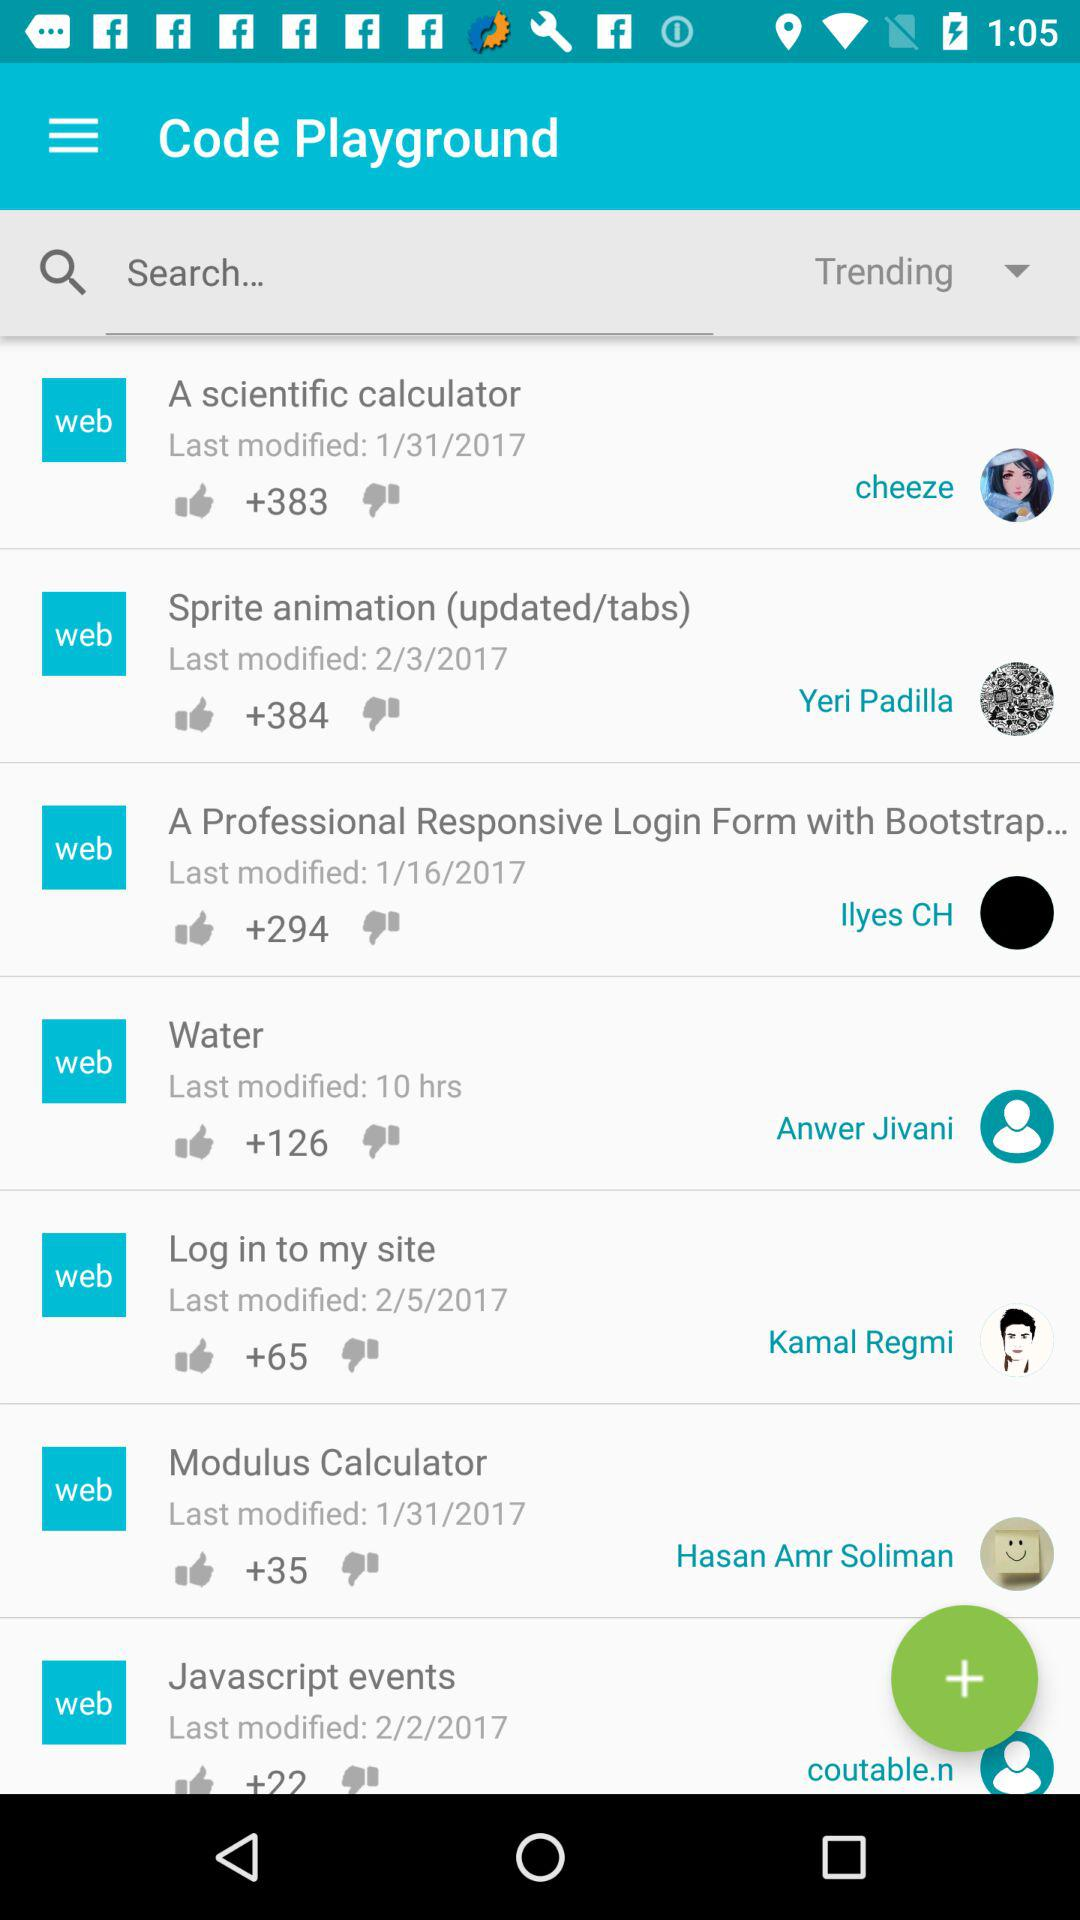What is the number of likes for the modulus calculator? The number of likes is 35. 